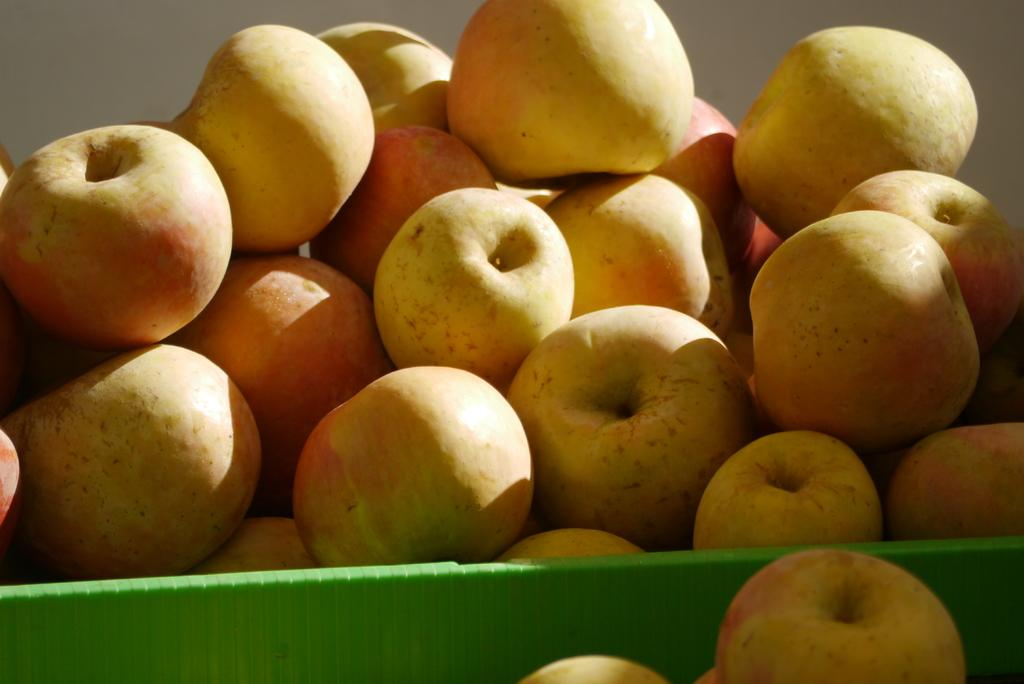What type of fruit is visible in the image? There are apple fruits in the image. How are the apple fruits arranged or contained in the image? The apple fruits are in a plastic basket. What type of quill can be seen in the image? There is no quill present in the image; it features apple fruits in a plastic basket. Where is the hall located in the image? There is no hall present in the image; it only contains apple fruits in a plastic basket. 